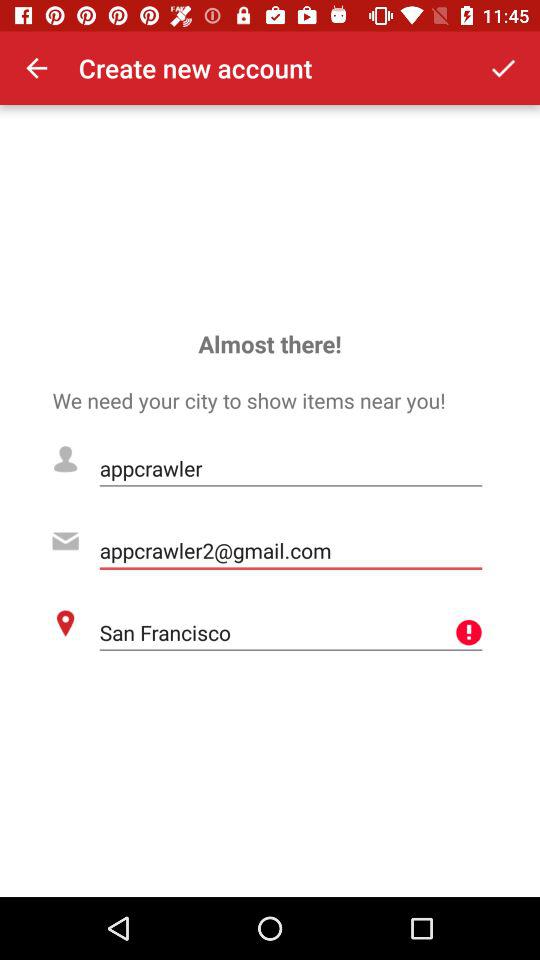What is the username? The username is "appcrawler". 